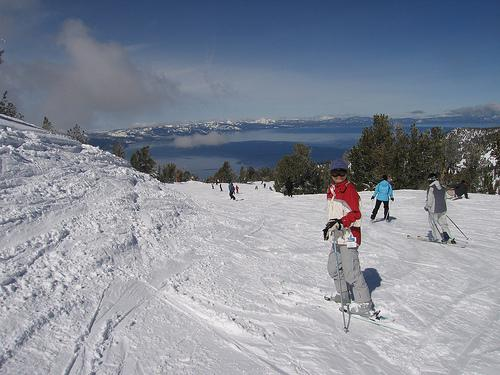Question: where are the people at?
Choices:
A. A home.
B. Ski resort.
C. A library.
D. A school.
Answer with the letter. Answer: B Question: what is in the background?
Choices:
A. Beach.
B. Home.
C. Ocean.
D. Sand.
Answer with the letter. Answer: C Question: what are the people doing?
Choices:
A. Skiing.
B. Skating.
C. Reading.
D. Joking.
Answer with the letter. Answer: A Question: what is on the people's feet?
Choices:
A. Skis.
B. Sandals.
C. Shoes.
D. Snowboards.
Answer with the letter. Answer: A 